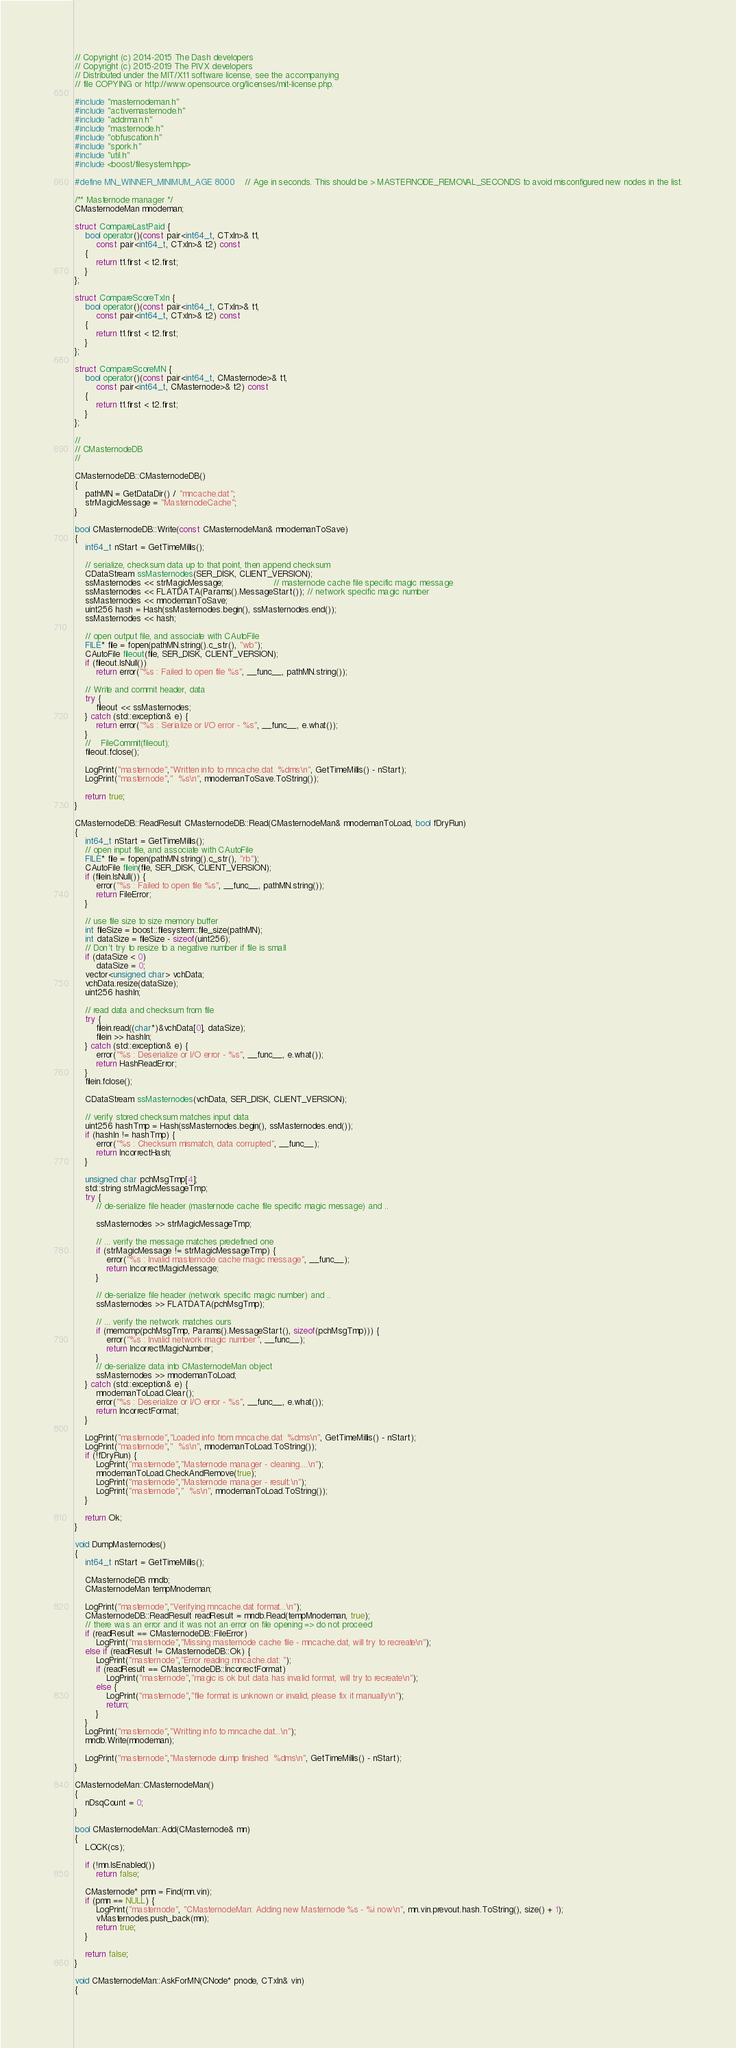<code> <loc_0><loc_0><loc_500><loc_500><_C++_>// Copyright (c) 2014-2015 The Dash developers
// Copyright (c) 2015-2019 The PIVX developers
// Distributed under the MIT/X11 software license, see the accompanying
// file COPYING or http://www.opensource.org/licenses/mit-license.php.

#include "masternodeman.h"
#include "activemasternode.h"
#include "addrman.h"
#include "masternode.h"
#include "obfuscation.h"
#include "spork.h"
#include "util.h"
#include <boost/filesystem.hpp>

#define MN_WINNER_MINIMUM_AGE 8000    // Age in seconds. This should be > MASTERNODE_REMOVAL_SECONDS to avoid misconfigured new nodes in the list.

/** Masternode manager */
CMasternodeMan mnodeman;

struct CompareLastPaid {
    bool operator()(const pair<int64_t, CTxIn>& t1,
        const pair<int64_t, CTxIn>& t2) const
    {
        return t1.first < t2.first;
    }
};

struct CompareScoreTxIn {
    bool operator()(const pair<int64_t, CTxIn>& t1,
        const pair<int64_t, CTxIn>& t2) const
    {
        return t1.first < t2.first;
    }
};

struct CompareScoreMN {
    bool operator()(const pair<int64_t, CMasternode>& t1,
        const pair<int64_t, CMasternode>& t2) const
    {
        return t1.first < t2.first;
    }
};

//
// CMasternodeDB
//

CMasternodeDB::CMasternodeDB()
{
    pathMN = GetDataDir() / "mncache.dat";
    strMagicMessage = "MasternodeCache";
}

bool CMasternodeDB::Write(const CMasternodeMan& mnodemanToSave)
{
    int64_t nStart = GetTimeMillis();

    // serialize, checksum data up to that point, then append checksum
    CDataStream ssMasternodes(SER_DISK, CLIENT_VERSION);
    ssMasternodes << strMagicMessage;                   // masternode cache file specific magic message
    ssMasternodes << FLATDATA(Params().MessageStart()); // network specific magic number
    ssMasternodes << mnodemanToSave;
    uint256 hash = Hash(ssMasternodes.begin(), ssMasternodes.end());
    ssMasternodes << hash;

    // open output file, and associate with CAutoFile
    FILE* file = fopen(pathMN.string().c_str(), "wb");
    CAutoFile fileout(file, SER_DISK, CLIENT_VERSION);
    if (fileout.IsNull())
        return error("%s : Failed to open file %s", __func__, pathMN.string());

    // Write and commit header, data
    try {
        fileout << ssMasternodes;
    } catch (std::exception& e) {
        return error("%s : Serialize or I/O error - %s", __func__, e.what());
    }
    //    FileCommit(fileout);
    fileout.fclose();

    LogPrint("masternode","Written info to mncache.dat  %dms\n", GetTimeMillis() - nStart);
    LogPrint("masternode","  %s\n", mnodemanToSave.ToString());

    return true;
}

CMasternodeDB::ReadResult CMasternodeDB::Read(CMasternodeMan& mnodemanToLoad, bool fDryRun)
{
    int64_t nStart = GetTimeMillis();
    // open input file, and associate with CAutoFile
    FILE* file = fopen(pathMN.string().c_str(), "rb");
    CAutoFile filein(file, SER_DISK, CLIENT_VERSION);
    if (filein.IsNull()) {
        error("%s : Failed to open file %s", __func__, pathMN.string());
        return FileError;
    }

    // use file size to size memory buffer
    int fileSize = boost::filesystem::file_size(pathMN);
    int dataSize = fileSize - sizeof(uint256);
    // Don't try to resize to a negative number if file is small
    if (dataSize < 0)
        dataSize = 0;
    vector<unsigned char> vchData;
    vchData.resize(dataSize);
    uint256 hashIn;

    // read data and checksum from file
    try {
        filein.read((char*)&vchData[0], dataSize);
        filein >> hashIn;
    } catch (std::exception& e) {
        error("%s : Deserialize or I/O error - %s", __func__, e.what());
        return HashReadError;
    }
    filein.fclose();

    CDataStream ssMasternodes(vchData, SER_DISK, CLIENT_VERSION);

    // verify stored checksum matches input data
    uint256 hashTmp = Hash(ssMasternodes.begin(), ssMasternodes.end());
    if (hashIn != hashTmp) {
        error("%s : Checksum mismatch, data corrupted", __func__);
        return IncorrectHash;
    }

    unsigned char pchMsgTmp[4];
    std::string strMagicMessageTmp;
    try {
        // de-serialize file header (masternode cache file specific magic message) and ..

        ssMasternodes >> strMagicMessageTmp;

        // ... verify the message matches predefined one
        if (strMagicMessage != strMagicMessageTmp) {
            error("%s : Invalid masternode cache magic message", __func__);
            return IncorrectMagicMessage;
        }

        // de-serialize file header (network specific magic number) and ..
        ssMasternodes >> FLATDATA(pchMsgTmp);

        // ... verify the network matches ours
        if (memcmp(pchMsgTmp, Params().MessageStart(), sizeof(pchMsgTmp))) {
            error("%s : Invalid network magic number", __func__);
            return IncorrectMagicNumber;
        }
        // de-serialize data into CMasternodeMan object
        ssMasternodes >> mnodemanToLoad;
    } catch (std::exception& e) {
        mnodemanToLoad.Clear();
        error("%s : Deserialize or I/O error - %s", __func__, e.what());
        return IncorrectFormat;
    }

    LogPrint("masternode","Loaded info from mncache.dat  %dms\n", GetTimeMillis() - nStart);
    LogPrint("masternode","  %s\n", mnodemanToLoad.ToString());
    if (!fDryRun) {
        LogPrint("masternode","Masternode manager - cleaning....\n");
        mnodemanToLoad.CheckAndRemove(true);
        LogPrint("masternode","Masternode manager - result:\n");
        LogPrint("masternode","  %s\n", mnodemanToLoad.ToString());
    }

    return Ok;
}

void DumpMasternodes()
{
    int64_t nStart = GetTimeMillis();

    CMasternodeDB mndb;
    CMasternodeMan tempMnodeman;

    LogPrint("masternode","Verifying mncache.dat format...\n");
    CMasternodeDB::ReadResult readResult = mndb.Read(tempMnodeman, true);
    // there was an error and it was not an error on file opening => do not proceed
    if (readResult == CMasternodeDB::FileError)
        LogPrint("masternode","Missing masternode cache file - mncache.dat, will try to recreate\n");
    else if (readResult != CMasternodeDB::Ok) {
        LogPrint("masternode","Error reading mncache.dat: ");
        if (readResult == CMasternodeDB::IncorrectFormat)
            LogPrint("masternode","magic is ok but data has invalid format, will try to recreate\n");
        else {
            LogPrint("masternode","file format is unknown or invalid, please fix it manually\n");
            return;
        }
    }
    LogPrint("masternode","Writting info to mncache.dat...\n");
    mndb.Write(mnodeman);

    LogPrint("masternode","Masternode dump finished  %dms\n", GetTimeMillis() - nStart);
}

CMasternodeMan::CMasternodeMan()
{
    nDsqCount = 0;
}

bool CMasternodeMan::Add(CMasternode& mn)
{
    LOCK(cs);

    if (!mn.IsEnabled())
        return false;

    CMasternode* pmn = Find(mn.vin);
    if (pmn == NULL) {
        LogPrint("masternode", "CMasternodeMan: Adding new Masternode %s - %i now\n", mn.vin.prevout.hash.ToString(), size() + 1);
        vMasternodes.push_back(mn);
        return true;
    }

    return false;
}

void CMasternodeMan::AskForMN(CNode* pnode, CTxIn& vin)
{</code> 